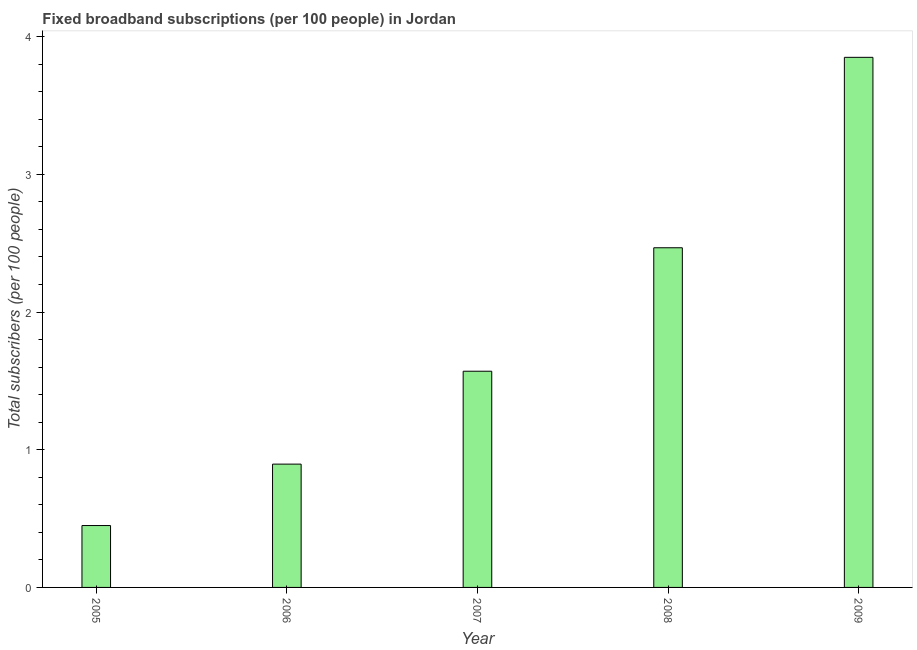Does the graph contain any zero values?
Give a very brief answer. No. What is the title of the graph?
Offer a very short reply. Fixed broadband subscriptions (per 100 people) in Jordan. What is the label or title of the X-axis?
Make the answer very short. Year. What is the label or title of the Y-axis?
Offer a terse response. Total subscribers (per 100 people). What is the total number of fixed broadband subscriptions in 2005?
Make the answer very short. 0.45. Across all years, what is the maximum total number of fixed broadband subscriptions?
Keep it short and to the point. 3.85. Across all years, what is the minimum total number of fixed broadband subscriptions?
Your answer should be compact. 0.45. In which year was the total number of fixed broadband subscriptions maximum?
Your answer should be compact. 2009. What is the sum of the total number of fixed broadband subscriptions?
Offer a very short reply. 9.23. What is the difference between the total number of fixed broadband subscriptions in 2008 and 2009?
Provide a short and direct response. -1.38. What is the average total number of fixed broadband subscriptions per year?
Your answer should be very brief. 1.85. What is the median total number of fixed broadband subscriptions?
Give a very brief answer. 1.57. What is the ratio of the total number of fixed broadband subscriptions in 2005 to that in 2006?
Offer a terse response. 0.5. What is the difference between the highest and the second highest total number of fixed broadband subscriptions?
Your answer should be compact. 1.38. Is the sum of the total number of fixed broadband subscriptions in 2006 and 2008 greater than the maximum total number of fixed broadband subscriptions across all years?
Your answer should be compact. No. In how many years, is the total number of fixed broadband subscriptions greater than the average total number of fixed broadband subscriptions taken over all years?
Keep it short and to the point. 2. How many bars are there?
Make the answer very short. 5. Are all the bars in the graph horizontal?
Provide a short and direct response. No. Are the values on the major ticks of Y-axis written in scientific E-notation?
Provide a short and direct response. No. What is the Total subscribers (per 100 people) in 2005?
Give a very brief answer. 0.45. What is the Total subscribers (per 100 people) of 2006?
Your answer should be very brief. 0.9. What is the Total subscribers (per 100 people) of 2007?
Provide a short and direct response. 1.57. What is the Total subscribers (per 100 people) of 2008?
Your response must be concise. 2.47. What is the Total subscribers (per 100 people) of 2009?
Give a very brief answer. 3.85. What is the difference between the Total subscribers (per 100 people) in 2005 and 2006?
Offer a very short reply. -0.45. What is the difference between the Total subscribers (per 100 people) in 2005 and 2007?
Your answer should be very brief. -1.12. What is the difference between the Total subscribers (per 100 people) in 2005 and 2008?
Provide a succinct answer. -2.02. What is the difference between the Total subscribers (per 100 people) in 2005 and 2009?
Offer a terse response. -3.4. What is the difference between the Total subscribers (per 100 people) in 2006 and 2007?
Offer a terse response. -0.67. What is the difference between the Total subscribers (per 100 people) in 2006 and 2008?
Ensure brevity in your answer.  -1.57. What is the difference between the Total subscribers (per 100 people) in 2006 and 2009?
Your answer should be compact. -2.95. What is the difference between the Total subscribers (per 100 people) in 2007 and 2008?
Provide a short and direct response. -0.9. What is the difference between the Total subscribers (per 100 people) in 2007 and 2009?
Your answer should be very brief. -2.28. What is the difference between the Total subscribers (per 100 people) in 2008 and 2009?
Ensure brevity in your answer.  -1.38. What is the ratio of the Total subscribers (per 100 people) in 2005 to that in 2006?
Your answer should be compact. 0.5. What is the ratio of the Total subscribers (per 100 people) in 2005 to that in 2007?
Provide a short and direct response. 0.29. What is the ratio of the Total subscribers (per 100 people) in 2005 to that in 2008?
Your answer should be compact. 0.18. What is the ratio of the Total subscribers (per 100 people) in 2005 to that in 2009?
Make the answer very short. 0.12. What is the ratio of the Total subscribers (per 100 people) in 2006 to that in 2007?
Offer a very short reply. 0.57. What is the ratio of the Total subscribers (per 100 people) in 2006 to that in 2008?
Ensure brevity in your answer.  0.36. What is the ratio of the Total subscribers (per 100 people) in 2006 to that in 2009?
Ensure brevity in your answer.  0.23. What is the ratio of the Total subscribers (per 100 people) in 2007 to that in 2008?
Offer a terse response. 0.64. What is the ratio of the Total subscribers (per 100 people) in 2007 to that in 2009?
Your response must be concise. 0.41. What is the ratio of the Total subscribers (per 100 people) in 2008 to that in 2009?
Make the answer very short. 0.64. 